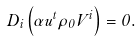Convert formula to latex. <formula><loc_0><loc_0><loc_500><loc_500>D _ { i } \left ( \alpha u ^ { t } \rho _ { 0 } V ^ { i } \right ) = 0 .</formula> 